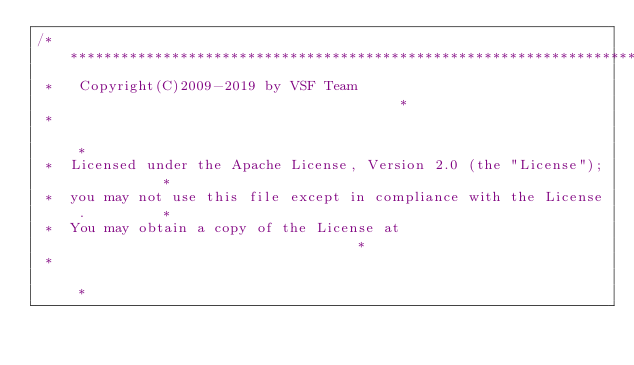<code> <loc_0><loc_0><loc_500><loc_500><_C_>/*****************************************************************************
 *   Copyright(C)2009-2019 by VSF Team                                       *
 *                                                                           *
 *  Licensed under the Apache License, Version 2.0 (the "License");          *
 *  you may not use this file except in compliance with the License.         *
 *  You may obtain a copy of the License at                                  *
 *                                                                           *</code> 